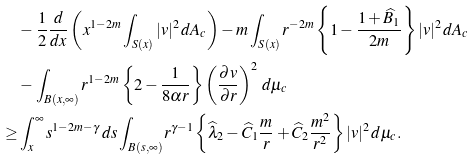Convert formula to latex. <formula><loc_0><loc_0><loc_500><loc_500>& - \frac { 1 } { 2 } \frac { d } { d x } \left ( x ^ { 1 - 2 m } \int _ { S ( x ) } | v | ^ { 2 } \, d A _ { c } \right ) - m \int _ { S ( x ) } r ^ { - 2 m } \left \{ 1 - \frac { 1 + \widehat { B } _ { 1 } } { 2 m } \right \} | v | ^ { 2 } \, d A _ { c } \\ & - \int _ { B ( x , \infty ) } r ^ { 1 - 2 m } \left \{ 2 - \frac { 1 } { 8 \alpha r } \right \} \left ( \frac { \partial v } { \partial r } \right ) ^ { 2 } \, d \mu _ { c } \\ \geq & \int _ { x } ^ { \infty } s ^ { 1 - 2 m - \gamma } \, d s \int _ { B ( s , \infty ) } r ^ { \gamma - 1 } \left \{ \widehat { \lambda } _ { 2 } - \widehat { C } _ { 1 } \frac { m } { r } + \widehat { C } _ { 2 } \frac { m ^ { 2 } } { r ^ { 2 } } \right \} | v | ^ { 2 } \, d \mu _ { c } .</formula> 